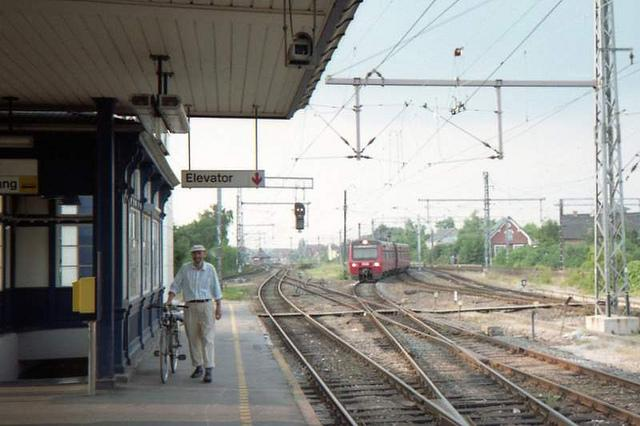What is the object hanging underneath the roof eave? Please explain your reasoning. camera. The purpose of the object hanging is to take footage. 